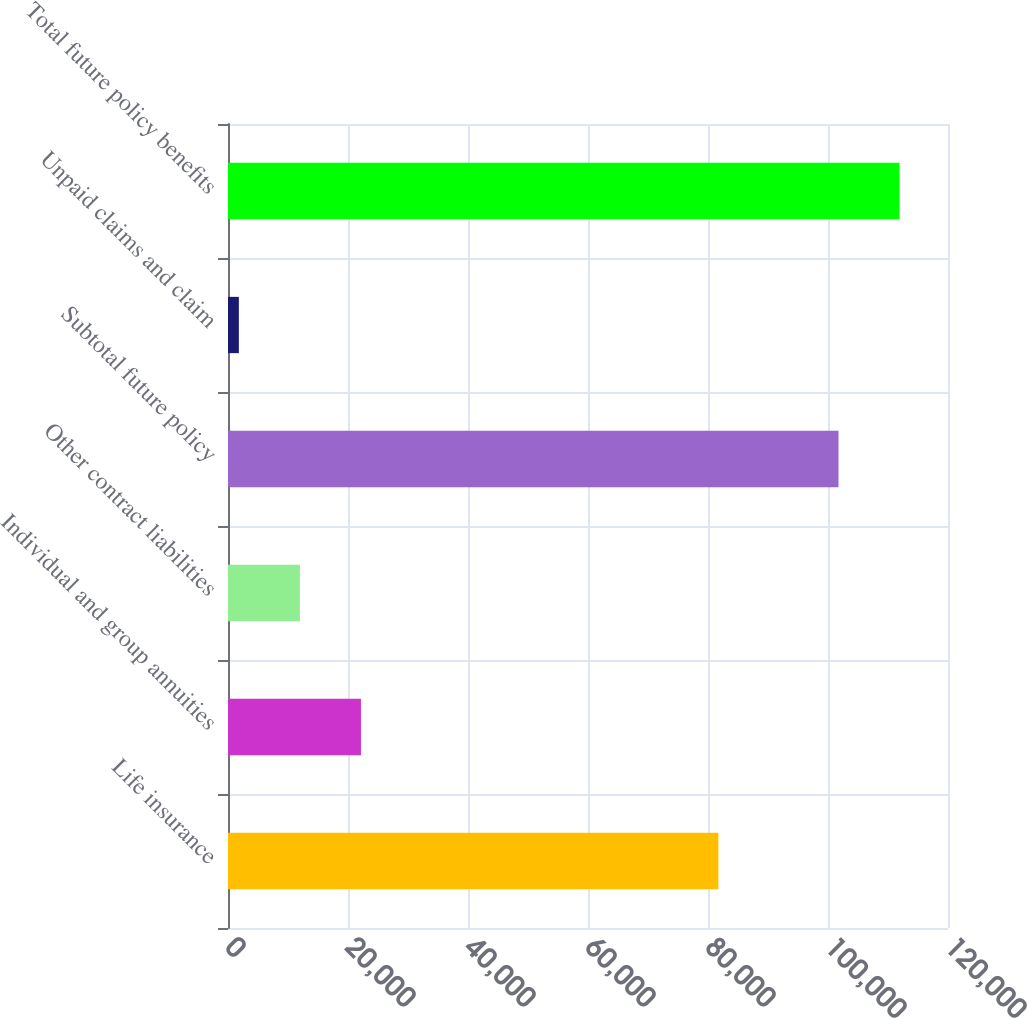Convert chart to OTSL. <chart><loc_0><loc_0><loc_500><loc_500><bar_chart><fcel>Life insurance<fcel>Individual and group annuities<fcel>Other contract liabilities<fcel>Subtotal future policy<fcel>Unpaid claims and claim<fcel>Total future policy benefits<nl><fcel>81729<fcel>22156.4<fcel>11981.7<fcel>101747<fcel>1807<fcel>111922<nl></chart> 